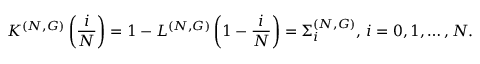<formula> <loc_0><loc_0><loc_500><loc_500>K ^ { ( N , G ) } \left ( \frac { i } { N } \right ) = 1 - L ^ { ( N , G ) } \left ( 1 - \frac { i } { N } \right ) = \Sigma _ { i } ^ { ( N , G ) } , \, i = 0 , 1 , \dots , N .</formula> 